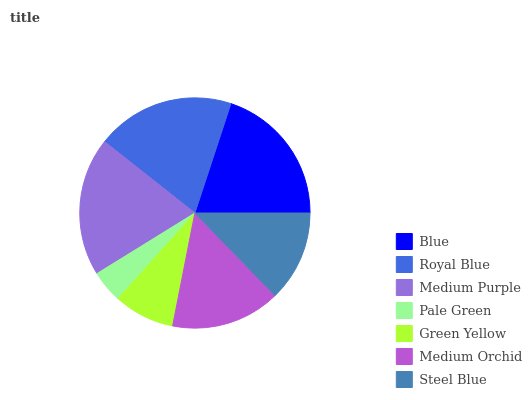Is Pale Green the minimum?
Answer yes or no. Yes. Is Blue the maximum?
Answer yes or no. Yes. Is Royal Blue the minimum?
Answer yes or no. No. Is Royal Blue the maximum?
Answer yes or no. No. Is Blue greater than Royal Blue?
Answer yes or no. Yes. Is Royal Blue less than Blue?
Answer yes or no. Yes. Is Royal Blue greater than Blue?
Answer yes or no. No. Is Blue less than Royal Blue?
Answer yes or no. No. Is Medium Orchid the high median?
Answer yes or no. Yes. Is Medium Orchid the low median?
Answer yes or no. Yes. Is Royal Blue the high median?
Answer yes or no. No. Is Royal Blue the low median?
Answer yes or no. No. 